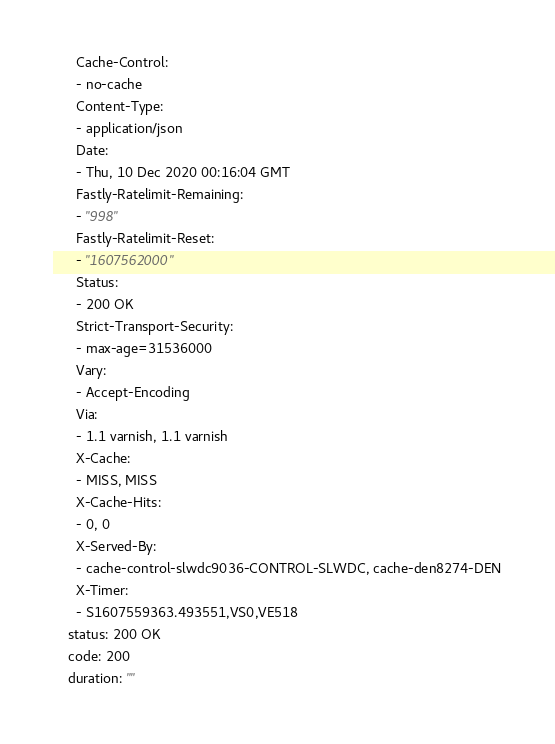<code> <loc_0><loc_0><loc_500><loc_500><_YAML_>      Cache-Control:
      - no-cache
      Content-Type:
      - application/json
      Date:
      - Thu, 10 Dec 2020 00:16:04 GMT
      Fastly-Ratelimit-Remaining:
      - "998"
      Fastly-Ratelimit-Reset:
      - "1607562000"
      Status:
      - 200 OK
      Strict-Transport-Security:
      - max-age=31536000
      Vary:
      - Accept-Encoding
      Via:
      - 1.1 varnish, 1.1 varnish
      X-Cache:
      - MISS, MISS
      X-Cache-Hits:
      - 0, 0
      X-Served-By:
      - cache-control-slwdc9036-CONTROL-SLWDC, cache-den8274-DEN
      X-Timer:
      - S1607559363.493551,VS0,VE518
    status: 200 OK
    code: 200
    duration: ""
</code> 